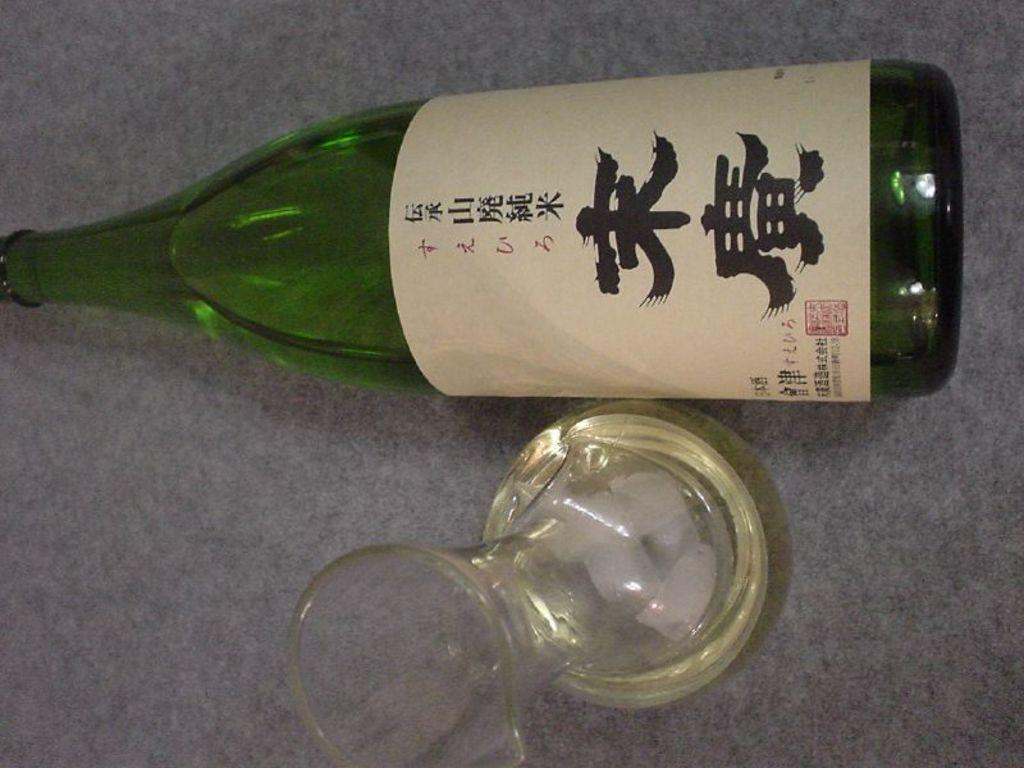What type of container is visible in the image? There is a glass in the image. What is the glass likely being used for? The glass is likely being used for holding a beverage, as there is a wine bottle in the image. What type of beverage might be in the glass? The glass might contain wine, as there is a wine bottle in the image. How many cacti are visible in the image? There are no cacti present in the image. What type of birds can be seen flying around the wine bottle? There are no birds visible in the image. 